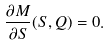<formula> <loc_0><loc_0><loc_500><loc_500>\frac { \partial M } { \partial S } ( S , Q ) = 0 .</formula> 